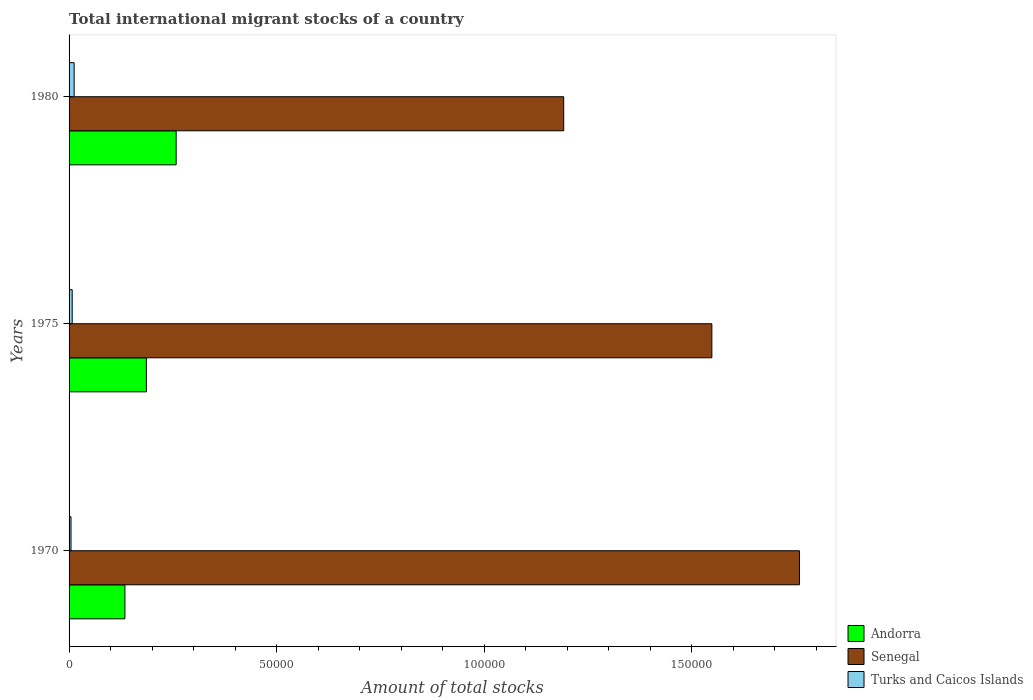How many different coloured bars are there?
Your answer should be compact. 3. How many groups of bars are there?
Provide a short and direct response. 3. Are the number of bars per tick equal to the number of legend labels?
Give a very brief answer. Yes. Are the number of bars on each tick of the Y-axis equal?
Keep it short and to the point. Yes. What is the label of the 2nd group of bars from the top?
Make the answer very short. 1975. In how many cases, is the number of bars for a given year not equal to the number of legend labels?
Your answer should be compact. 0. What is the amount of total stocks in in Turks and Caicos Islands in 1975?
Your answer should be compact. 756. Across all years, what is the maximum amount of total stocks in in Andorra?
Provide a short and direct response. 2.58e+04. Across all years, what is the minimum amount of total stocks in in Senegal?
Make the answer very short. 1.19e+05. In which year was the amount of total stocks in in Senegal maximum?
Keep it short and to the point. 1970. In which year was the amount of total stocks in in Senegal minimum?
Your response must be concise. 1980. What is the total amount of total stocks in in Turks and Caicos Islands in the graph?
Make the answer very short. 2450. What is the difference between the amount of total stocks in in Turks and Caicos Islands in 1970 and that in 1980?
Make the answer very short. -756. What is the difference between the amount of total stocks in in Andorra in 1980 and the amount of total stocks in in Senegal in 1975?
Provide a short and direct response. -1.29e+05. What is the average amount of total stocks in in Senegal per year?
Offer a very short reply. 1.50e+05. In the year 1970, what is the difference between the amount of total stocks in in Turks and Caicos Islands and amount of total stocks in in Andorra?
Ensure brevity in your answer.  -1.30e+04. What is the ratio of the amount of total stocks in in Andorra in 1975 to that in 1980?
Provide a succinct answer. 0.72. Is the difference between the amount of total stocks in in Turks and Caicos Islands in 1970 and 1980 greater than the difference between the amount of total stocks in in Andorra in 1970 and 1980?
Provide a short and direct response. Yes. What is the difference between the highest and the second highest amount of total stocks in in Senegal?
Offer a terse response. 2.11e+04. What is the difference between the highest and the lowest amount of total stocks in in Senegal?
Ensure brevity in your answer.  5.68e+04. In how many years, is the amount of total stocks in in Andorra greater than the average amount of total stocks in in Andorra taken over all years?
Keep it short and to the point. 1. What does the 1st bar from the top in 1980 represents?
Offer a very short reply. Turks and Caicos Islands. What does the 1st bar from the bottom in 1980 represents?
Provide a short and direct response. Andorra. How many years are there in the graph?
Keep it short and to the point. 3. Are the values on the major ticks of X-axis written in scientific E-notation?
Your answer should be compact. No. Does the graph contain grids?
Offer a very short reply. No. How many legend labels are there?
Make the answer very short. 3. What is the title of the graph?
Ensure brevity in your answer.  Total international migrant stocks of a country. What is the label or title of the X-axis?
Your answer should be very brief. Amount of total stocks. What is the Amount of total stocks in Andorra in 1970?
Give a very brief answer. 1.34e+04. What is the Amount of total stocks in Senegal in 1970?
Offer a very short reply. 1.76e+05. What is the Amount of total stocks in Turks and Caicos Islands in 1970?
Provide a short and direct response. 469. What is the Amount of total stocks of Andorra in 1975?
Provide a short and direct response. 1.86e+04. What is the Amount of total stocks in Senegal in 1975?
Make the answer very short. 1.55e+05. What is the Amount of total stocks in Turks and Caicos Islands in 1975?
Your response must be concise. 756. What is the Amount of total stocks in Andorra in 1980?
Provide a succinct answer. 2.58e+04. What is the Amount of total stocks in Senegal in 1980?
Give a very brief answer. 1.19e+05. What is the Amount of total stocks of Turks and Caicos Islands in 1980?
Your response must be concise. 1225. Across all years, what is the maximum Amount of total stocks of Andorra?
Give a very brief answer. 2.58e+04. Across all years, what is the maximum Amount of total stocks in Senegal?
Keep it short and to the point. 1.76e+05. Across all years, what is the maximum Amount of total stocks in Turks and Caicos Islands?
Provide a succinct answer. 1225. Across all years, what is the minimum Amount of total stocks in Andorra?
Make the answer very short. 1.34e+04. Across all years, what is the minimum Amount of total stocks in Senegal?
Your answer should be compact. 1.19e+05. Across all years, what is the minimum Amount of total stocks of Turks and Caicos Islands?
Ensure brevity in your answer.  469. What is the total Amount of total stocks of Andorra in the graph?
Your answer should be compact. 5.79e+04. What is the total Amount of total stocks of Senegal in the graph?
Provide a short and direct response. 4.50e+05. What is the total Amount of total stocks in Turks and Caicos Islands in the graph?
Keep it short and to the point. 2450. What is the difference between the Amount of total stocks in Andorra in 1970 and that in 1975?
Ensure brevity in your answer.  -5177. What is the difference between the Amount of total stocks in Senegal in 1970 and that in 1975?
Ensure brevity in your answer.  2.11e+04. What is the difference between the Amount of total stocks of Turks and Caicos Islands in 1970 and that in 1975?
Keep it short and to the point. -287. What is the difference between the Amount of total stocks of Andorra in 1970 and that in 1980?
Provide a succinct answer. -1.23e+04. What is the difference between the Amount of total stocks in Senegal in 1970 and that in 1980?
Provide a short and direct response. 5.68e+04. What is the difference between the Amount of total stocks of Turks and Caicos Islands in 1970 and that in 1980?
Provide a short and direct response. -756. What is the difference between the Amount of total stocks of Andorra in 1975 and that in 1980?
Your answer should be very brief. -7169. What is the difference between the Amount of total stocks in Senegal in 1975 and that in 1980?
Keep it short and to the point. 3.57e+04. What is the difference between the Amount of total stocks of Turks and Caicos Islands in 1975 and that in 1980?
Provide a short and direct response. -469. What is the difference between the Amount of total stocks in Andorra in 1970 and the Amount of total stocks in Senegal in 1975?
Give a very brief answer. -1.41e+05. What is the difference between the Amount of total stocks of Andorra in 1970 and the Amount of total stocks of Turks and Caicos Islands in 1975?
Offer a very short reply. 1.27e+04. What is the difference between the Amount of total stocks of Senegal in 1970 and the Amount of total stocks of Turks and Caicos Islands in 1975?
Provide a succinct answer. 1.75e+05. What is the difference between the Amount of total stocks of Andorra in 1970 and the Amount of total stocks of Senegal in 1980?
Make the answer very short. -1.06e+05. What is the difference between the Amount of total stocks of Andorra in 1970 and the Amount of total stocks of Turks and Caicos Islands in 1980?
Keep it short and to the point. 1.22e+04. What is the difference between the Amount of total stocks of Senegal in 1970 and the Amount of total stocks of Turks and Caicos Islands in 1980?
Provide a short and direct response. 1.75e+05. What is the difference between the Amount of total stocks in Andorra in 1975 and the Amount of total stocks in Senegal in 1980?
Your response must be concise. -1.01e+05. What is the difference between the Amount of total stocks of Andorra in 1975 and the Amount of total stocks of Turks and Caicos Islands in 1980?
Provide a succinct answer. 1.74e+04. What is the difference between the Amount of total stocks in Senegal in 1975 and the Amount of total stocks in Turks and Caicos Islands in 1980?
Your answer should be compact. 1.54e+05. What is the average Amount of total stocks in Andorra per year?
Provide a succinct answer. 1.93e+04. What is the average Amount of total stocks in Senegal per year?
Offer a very short reply. 1.50e+05. What is the average Amount of total stocks of Turks and Caicos Islands per year?
Your response must be concise. 816.67. In the year 1970, what is the difference between the Amount of total stocks of Andorra and Amount of total stocks of Senegal?
Offer a terse response. -1.62e+05. In the year 1970, what is the difference between the Amount of total stocks of Andorra and Amount of total stocks of Turks and Caicos Islands?
Make the answer very short. 1.30e+04. In the year 1970, what is the difference between the Amount of total stocks in Senegal and Amount of total stocks in Turks and Caicos Islands?
Your answer should be compact. 1.75e+05. In the year 1975, what is the difference between the Amount of total stocks in Andorra and Amount of total stocks in Senegal?
Keep it short and to the point. -1.36e+05. In the year 1975, what is the difference between the Amount of total stocks in Andorra and Amount of total stocks in Turks and Caicos Islands?
Give a very brief answer. 1.79e+04. In the year 1975, what is the difference between the Amount of total stocks of Senegal and Amount of total stocks of Turks and Caicos Islands?
Your answer should be compact. 1.54e+05. In the year 1980, what is the difference between the Amount of total stocks in Andorra and Amount of total stocks in Senegal?
Give a very brief answer. -9.33e+04. In the year 1980, what is the difference between the Amount of total stocks of Andorra and Amount of total stocks of Turks and Caicos Islands?
Your response must be concise. 2.46e+04. In the year 1980, what is the difference between the Amount of total stocks in Senegal and Amount of total stocks in Turks and Caicos Islands?
Ensure brevity in your answer.  1.18e+05. What is the ratio of the Amount of total stocks in Andorra in 1970 to that in 1975?
Make the answer very short. 0.72. What is the ratio of the Amount of total stocks of Senegal in 1970 to that in 1975?
Your response must be concise. 1.14. What is the ratio of the Amount of total stocks in Turks and Caicos Islands in 1970 to that in 1975?
Give a very brief answer. 0.62. What is the ratio of the Amount of total stocks of Andorra in 1970 to that in 1980?
Keep it short and to the point. 0.52. What is the ratio of the Amount of total stocks of Senegal in 1970 to that in 1980?
Your answer should be compact. 1.48. What is the ratio of the Amount of total stocks of Turks and Caicos Islands in 1970 to that in 1980?
Keep it short and to the point. 0.38. What is the ratio of the Amount of total stocks in Andorra in 1975 to that in 1980?
Provide a succinct answer. 0.72. What is the ratio of the Amount of total stocks of Senegal in 1975 to that in 1980?
Provide a short and direct response. 1.3. What is the ratio of the Amount of total stocks of Turks and Caicos Islands in 1975 to that in 1980?
Your answer should be compact. 0.62. What is the difference between the highest and the second highest Amount of total stocks of Andorra?
Keep it short and to the point. 7169. What is the difference between the highest and the second highest Amount of total stocks of Senegal?
Keep it short and to the point. 2.11e+04. What is the difference between the highest and the second highest Amount of total stocks in Turks and Caicos Islands?
Keep it short and to the point. 469. What is the difference between the highest and the lowest Amount of total stocks in Andorra?
Your answer should be compact. 1.23e+04. What is the difference between the highest and the lowest Amount of total stocks of Senegal?
Provide a short and direct response. 5.68e+04. What is the difference between the highest and the lowest Amount of total stocks in Turks and Caicos Islands?
Your answer should be very brief. 756. 